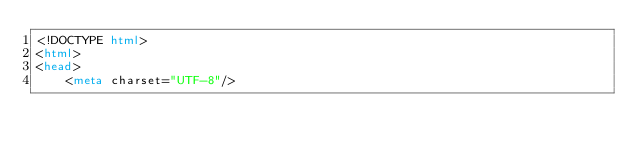Convert code to text. <code><loc_0><loc_0><loc_500><loc_500><_HTML_><!DOCTYPE html>
<html>
<head>
    <meta charset="UTF-8"/>
</code> 